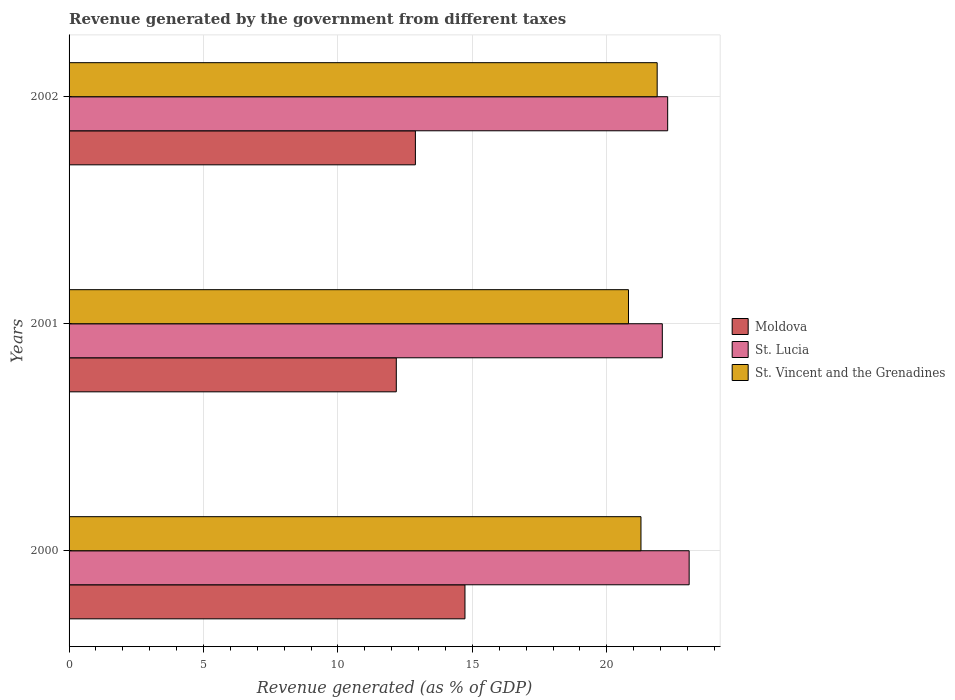How many different coloured bars are there?
Keep it short and to the point. 3. How many bars are there on the 2nd tick from the bottom?
Your response must be concise. 3. What is the label of the 1st group of bars from the top?
Provide a short and direct response. 2002. In how many cases, is the number of bars for a given year not equal to the number of legend labels?
Ensure brevity in your answer.  0. What is the revenue generated by the government in St. Vincent and the Grenadines in 2000?
Provide a succinct answer. 21.27. Across all years, what is the maximum revenue generated by the government in St. Vincent and the Grenadines?
Keep it short and to the point. 21.88. Across all years, what is the minimum revenue generated by the government in St. Lucia?
Your response must be concise. 22.07. What is the total revenue generated by the government in St. Vincent and the Grenadines in the graph?
Make the answer very short. 63.96. What is the difference between the revenue generated by the government in St. Lucia in 2001 and that in 2002?
Keep it short and to the point. -0.2. What is the difference between the revenue generated by the government in Moldova in 2001 and the revenue generated by the government in St. Lucia in 2002?
Offer a very short reply. -10.09. What is the average revenue generated by the government in St. Vincent and the Grenadines per year?
Provide a short and direct response. 21.32. In the year 2000, what is the difference between the revenue generated by the government in St. Lucia and revenue generated by the government in St. Vincent and the Grenadines?
Provide a short and direct response. 1.79. What is the ratio of the revenue generated by the government in Moldova in 2000 to that in 2002?
Your answer should be compact. 1.14. Is the difference between the revenue generated by the government in St. Lucia in 2000 and 2001 greater than the difference between the revenue generated by the government in St. Vincent and the Grenadines in 2000 and 2001?
Give a very brief answer. Yes. What is the difference between the highest and the second highest revenue generated by the government in St. Vincent and the Grenadines?
Keep it short and to the point. 0.6. What is the difference between the highest and the lowest revenue generated by the government in Moldova?
Your answer should be compact. 2.55. What does the 1st bar from the top in 2002 represents?
Your answer should be compact. St. Vincent and the Grenadines. What does the 1st bar from the bottom in 2000 represents?
Your response must be concise. Moldova. How many bars are there?
Ensure brevity in your answer.  9. Are all the bars in the graph horizontal?
Offer a terse response. Yes. How many years are there in the graph?
Provide a short and direct response. 3. Are the values on the major ticks of X-axis written in scientific E-notation?
Provide a short and direct response. No. How are the legend labels stacked?
Your response must be concise. Vertical. What is the title of the graph?
Ensure brevity in your answer.  Revenue generated by the government from different taxes. Does "Latvia" appear as one of the legend labels in the graph?
Ensure brevity in your answer.  No. What is the label or title of the X-axis?
Provide a short and direct response. Revenue generated (as % of GDP). What is the Revenue generated (as % of GDP) in Moldova in 2000?
Offer a very short reply. 14.73. What is the Revenue generated (as % of GDP) of St. Lucia in 2000?
Offer a terse response. 23.06. What is the Revenue generated (as % of GDP) in St. Vincent and the Grenadines in 2000?
Your answer should be compact. 21.27. What is the Revenue generated (as % of GDP) of Moldova in 2001?
Offer a very short reply. 12.17. What is the Revenue generated (as % of GDP) of St. Lucia in 2001?
Your answer should be very brief. 22.07. What is the Revenue generated (as % of GDP) of St. Vincent and the Grenadines in 2001?
Give a very brief answer. 20.81. What is the Revenue generated (as % of GDP) in Moldova in 2002?
Your answer should be very brief. 12.88. What is the Revenue generated (as % of GDP) in St. Lucia in 2002?
Ensure brevity in your answer.  22.27. What is the Revenue generated (as % of GDP) in St. Vincent and the Grenadines in 2002?
Your answer should be very brief. 21.88. Across all years, what is the maximum Revenue generated (as % of GDP) of Moldova?
Offer a terse response. 14.73. Across all years, what is the maximum Revenue generated (as % of GDP) in St. Lucia?
Ensure brevity in your answer.  23.06. Across all years, what is the maximum Revenue generated (as % of GDP) in St. Vincent and the Grenadines?
Your answer should be compact. 21.88. Across all years, what is the minimum Revenue generated (as % of GDP) of Moldova?
Provide a short and direct response. 12.17. Across all years, what is the minimum Revenue generated (as % of GDP) in St. Lucia?
Offer a terse response. 22.07. Across all years, what is the minimum Revenue generated (as % of GDP) of St. Vincent and the Grenadines?
Give a very brief answer. 20.81. What is the total Revenue generated (as % of GDP) in Moldova in the graph?
Offer a very short reply. 39.78. What is the total Revenue generated (as % of GDP) in St. Lucia in the graph?
Keep it short and to the point. 67.4. What is the total Revenue generated (as % of GDP) in St. Vincent and the Grenadines in the graph?
Keep it short and to the point. 63.96. What is the difference between the Revenue generated (as % of GDP) in Moldova in 2000 and that in 2001?
Keep it short and to the point. 2.55. What is the difference between the Revenue generated (as % of GDP) of St. Lucia in 2000 and that in 2001?
Provide a succinct answer. 1. What is the difference between the Revenue generated (as % of GDP) in St. Vincent and the Grenadines in 2000 and that in 2001?
Your response must be concise. 0.46. What is the difference between the Revenue generated (as % of GDP) of Moldova in 2000 and that in 2002?
Your response must be concise. 1.84. What is the difference between the Revenue generated (as % of GDP) in St. Lucia in 2000 and that in 2002?
Your response must be concise. 0.8. What is the difference between the Revenue generated (as % of GDP) in St. Vincent and the Grenadines in 2000 and that in 2002?
Provide a short and direct response. -0.6. What is the difference between the Revenue generated (as % of GDP) of Moldova in 2001 and that in 2002?
Keep it short and to the point. -0.71. What is the difference between the Revenue generated (as % of GDP) in St. Lucia in 2001 and that in 2002?
Your response must be concise. -0.2. What is the difference between the Revenue generated (as % of GDP) in St. Vincent and the Grenadines in 2001 and that in 2002?
Ensure brevity in your answer.  -1.07. What is the difference between the Revenue generated (as % of GDP) of Moldova in 2000 and the Revenue generated (as % of GDP) of St. Lucia in 2001?
Provide a succinct answer. -7.34. What is the difference between the Revenue generated (as % of GDP) of Moldova in 2000 and the Revenue generated (as % of GDP) of St. Vincent and the Grenadines in 2001?
Give a very brief answer. -6.08. What is the difference between the Revenue generated (as % of GDP) in St. Lucia in 2000 and the Revenue generated (as % of GDP) in St. Vincent and the Grenadines in 2001?
Offer a terse response. 2.26. What is the difference between the Revenue generated (as % of GDP) in Moldova in 2000 and the Revenue generated (as % of GDP) in St. Lucia in 2002?
Your answer should be very brief. -7.54. What is the difference between the Revenue generated (as % of GDP) of Moldova in 2000 and the Revenue generated (as % of GDP) of St. Vincent and the Grenadines in 2002?
Keep it short and to the point. -7.15. What is the difference between the Revenue generated (as % of GDP) of St. Lucia in 2000 and the Revenue generated (as % of GDP) of St. Vincent and the Grenadines in 2002?
Make the answer very short. 1.19. What is the difference between the Revenue generated (as % of GDP) of Moldova in 2001 and the Revenue generated (as % of GDP) of St. Lucia in 2002?
Offer a terse response. -10.09. What is the difference between the Revenue generated (as % of GDP) of Moldova in 2001 and the Revenue generated (as % of GDP) of St. Vincent and the Grenadines in 2002?
Provide a short and direct response. -9.7. What is the difference between the Revenue generated (as % of GDP) in St. Lucia in 2001 and the Revenue generated (as % of GDP) in St. Vincent and the Grenadines in 2002?
Your response must be concise. 0.19. What is the average Revenue generated (as % of GDP) in Moldova per year?
Make the answer very short. 13.26. What is the average Revenue generated (as % of GDP) of St. Lucia per year?
Provide a short and direct response. 22.47. What is the average Revenue generated (as % of GDP) of St. Vincent and the Grenadines per year?
Keep it short and to the point. 21.32. In the year 2000, what is the difference between the Revenue generated (as % of GDP) in Moldova and Revenue generated (as % of GDP) in St. Lucia?
Your answer should be compact. -8.34. In the year 2000, what is the difference between the Revenue generated (as % of GDP) in Moldova and Revenue generated (as % of GDP) in St. Vincent and the Grenadines?
Offer a terse response. -6.55. In the year 2000, what is the difference between the Revenue generated (as % of GDP) of St. Lucia and Revenue generated (as % of GDP) of St. Vincent and the Grenadines?
Provide a succinct answer. 1.79. In the year 2001, what is the difference between the Revenue generated (as % of GDP) of Moldova and Revenue generated (as % of GDP) of St. Lucia?
Make the answer very short. -9.89. In the year 2001, what is the difference between the Revenue generated (as % of GDP) in Moldova and Revenue generated (as % of GDP) in St. Vincent and the Grenadines?
Your response must be concise. -8.64. In the year 2001, what is the difference between the Revenue generated (as % of GDP) of St. Lucia and Revenue generated (as % of GDP) of St. Vincent and the Grenadines?
Your answer should be compact. 1.26. In the year 2002, what is the difference between the Revenue generated (as % of GDP) in Moldova and Revenue generated (as % of GDP) in St. Lucia?
Your response must be concise. -9.38. In the year 2002, what is the difference between the Revenue generated (as % of GDP) of Moldova and Revenue generated (as % of GDP) of St. Vincent and the Grenadines?
Keep it short and to the point. -8.99. In the year 2002, what is the difference between the Revenue generated (as % of GDP) in St. Lucia and Revenue generated (as % of GDP) in St. Vincent and the Grenadines?
Ensure brevity in your answer.  0.39. What is the ratio of the Revenue generated (as % of GDP) of Moldova in 2000 to that in 2001?
Your answer should be compact. 1.21. What is the ratio of the Revenue generated (as % of GDP) of St. Lucia in 2000 to that in 2001?
Offer a terse response. 1.05. What is the ratio of the Revenue generated (as % of GDP) in St. Vincent and the Grenadines in 2000 to that in 2001?
Make the answer very short. 1.02. What is the ratio of the Revenue generated (as % of GDP) of Moldova in 2000 to that in 2002?
Your answer should be very brief. 1.14. What is the ratio of the Revenue generated (as % of GDP) of St. Lucia in 2000 to that in 2002?
Provide a short and direct response. 1.04. What is the ratio of the Revenue generated (as % of GDP) in St. Vincent and the Grenadines in 2000 to that in 2002?
Give a very brief answer. 0.97. What is the ratio of the Revenue generated (as % of GDP) in Moldova in 2001 to that in 2002?
Ensure brevity in your answer.  0.94. What is the ratio of the Revenue generated (as % of GDP) in St. Lucia in 2001 to that in 2002?
Your answer should be very brief. 0.99. What is the ratio of the Revenue generated (as % of GDP) in St. Vincent and the Grenadines in 2001 to that in 2002?
Your response must be concise. 0.95. What is the difference between the highest and the second highest Revenue generated (as % of GDP) in Moldova?
Ensure brevity in your answer.  1.84. What is the difference between the highest and the second highest Revenue generated (as % of GDP) of St. Lucia?
Offer a very short reply. 0.8. What is the difference between the highest and the second highest Revenue generated (as % of GDP) of St. Vincent and the Grenadines?
Your response must be concise. 0.6. What is the difference between the highest and the lowest Revenue generated (as % of GDP) in Moldova?
Provide a succinct answer. 2.55. What is the difference between the highest and the lowest Revenue generated (as % of GDP) in St. Vincent and the Grenadines?
Make the answer very short. 1.07. 